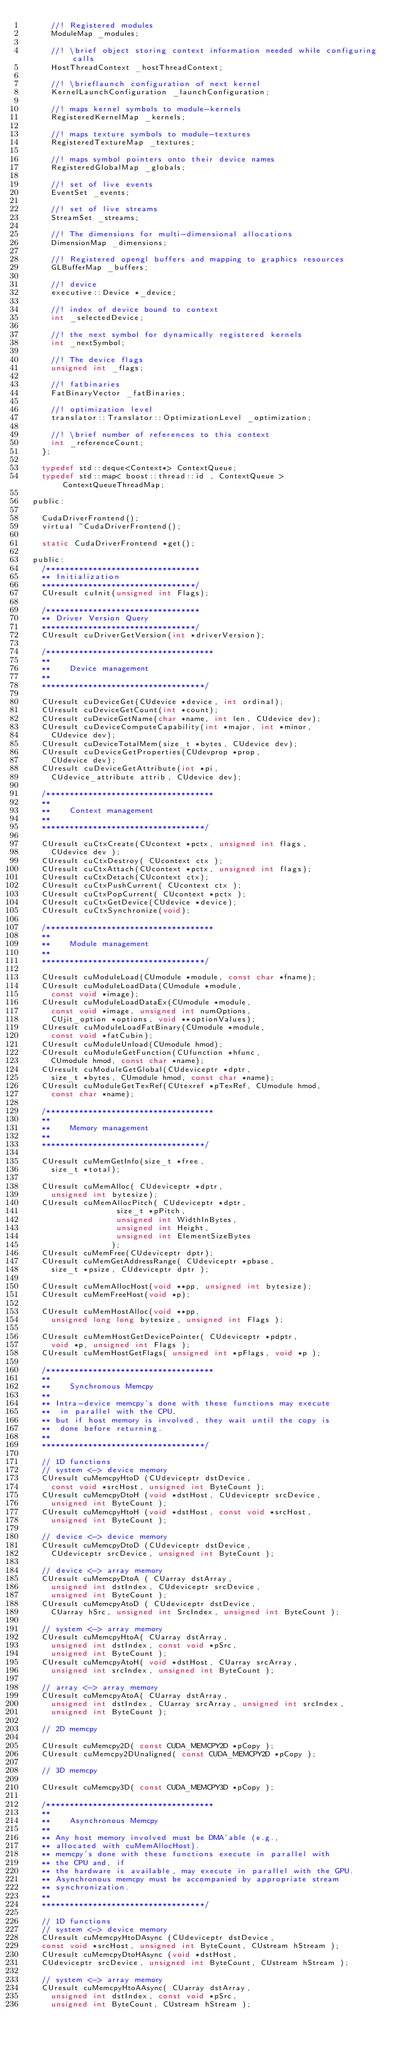<code> <loc_0><loc_0><loc_500><loc_500><_C_>			//! Registered modules
			ModuleMap _modules;
		
			//! \brief object storing context information needed while configuring calls
			HostThreadContext _hostThreadContext;
			
			//! \brieflaunch configuration of next kernel
			KernelLaunchConfiguration _launchConfiguration;
		
			//! maps kernel symbols to module-kernels
			RegisteredKernelMap _kernels;
		
			//! maps texture symbols to module-textures
			RegisteredTextureMap _textures;

			//! maps symbol pointers onto their device names
			RegisteredGlobalMap _globals;
			
			//! set of live events
			EventSet _events;
			
			//! set of live streams
			StreamSet _streams;
		
			//! The dimensions for multi-dimensional allocations
			DimensionMap _dimensions;
		
			//! Registered opengl buffers and mapping to graphics resources
			GLBufferMap _buffers;
		
			//! device
			executive::Device *_device;
			
			//! index of device bound to context
			int _selectedDevice;
		
			//! the next symbol for dynamically registered kernels
			int _nextSymbol;
		
			//! The device flags
			unsigned int _flags;
		
			//! fatbinaries
			FatBinaryVector _fatBinaries;

			//! optimization level
			translator::Translator::OptimizationLevel _optimization;

			//! \brief number of references to this context
			int _referenceCount;
		};

		typedef std::deque<Context*> ContextQueue;
		typedef std::map< boost::thread::id , ContextQueue > ContextQueueThreadMap;

	public:

		CudaDriverFrontend();
		virtual ~CudaDriverFrontend();

		static CudaDriverFrontend *get();

	public:
		/*********************************
		** Initialization
		*********************************/
		CUresult cuInit(unsigned int Flags);

		/*********************************
		** Driver Version Query
		*********************************/
		CUresult cuDriverGetVersion(int *driverVersion);

		/************************************
		**
		**    Device management
		**
		***********************************/

		CUresult cuDeviceGet(CUdevice *device, int ordinal);
		CUresult cuDeviceGetCount(int *count);
		CUresult cuDeviceGetName(char *name, int len, CUdevice dev);
		CUresult cuDeviceComputeCapability(int *major, int *minor, 
			CUdevice dev);
		CUresult cuDeviceTotalMem(size_t *bytes, CUdevice dev);
		CUresult cuDeviceGetProperties(CUdevprop *prop, 
			CUdevice dev);
		CUresult cuDeviceGetAttribute(int *pi, 
			CUdevice_attribute attrib, CUdevice dev);

		/************************************
		**
		**    Context management
		**
		***********************************/

		CUresult cuCtxCreate(CUcontext *pctx, unsigned int flags, 
			CUdevice dev );
		CUresult cuCtxDestroy( CUcontext ctx );
		CUresult cuCtxAttach(CUcontext *pctx, unsigned int flags);
		CUresult cuCtxDetach(CUcontext ctx);
		CUresult cuCtxPushCurrent( CUcontext ctx );
		CUresult cuCtxPopCurrent( CUcontext *pctx );
		CUresult cuCtxGetDevice(CUdevice *device);
		CUresult cuCtxSynchronize(void);

		/************************************
		**
		**    Module management
		**
		***********************************/

		CUresult cuModuleLoad(CUmodule *module, const char *fname);
		CUresult cuModuleLoadData(CUmodule *module, 
			const void *image);
		CUresult cuModuleLoadDataEx(CUmodule *module, 
			const void *image, unsigned int numOptions, 
			CUjit_option *options, void **optionValues);
		CUresult cuModuleLoadFatBinary(CUmodule *module, 
			const void *fatCubin);
		CUresult cuModuleUnload(CUmodule hmod);
		CUresult cuModuleGetFunction(CUfunction *hfunc, 
			CUmodule hmod, const char *name);
		CUresult cuModuleGetGlobal(CUdeviceptr *dptr, 
			size_t *bytes, CUmodule hmod, const char *name);
		CUresult cuModuleGetTexRef(CUtexref *pTexRef, CUmodule hmod, 
			const char *name);

		/************************************
		**
		**    Memory management
		**
		***********************************/

		CUresult cuMemGetInfo(size_t *free, 
			size_t *total);

		CUresult cuMemAlloc( CUdeviceptr *dptr, 
			unsigned int bytesize);
		CUresult cuMemAllocPitch( CUdeviceptr *dptr, 
					          size_t *pPitch,
					          unsigned int WidthInBytes, 
					          unsigned int Height, 
					          unsigned int ElementSizeBytes
					         );
		CUresult cuMemFree(CUdeviceptr dptr);
		CUresult cuMemGetAddressRange( CUdeviceptr *pbase, 
			size_t *psize, CUdeviceptr dptr );

		CUresult cuMemAllocHost(void **pp, unsigned int bytesize);
		CUresult cuMemFreeHost(void *p);

		CUresult cuMemHostAlloc(void **pp, 
			unsigned long long bytesize, unsigned int Flags );

		CUresult cuMemHostGetDevicePointer( CUdeviceptr *pdptr, 
			void *p, unsigned int Flags );
		CUresult cuMemHostGetFlags( unsigned int *pFlags, void *p );

		/************************************
		**
		**    Synchronous Memcpy
		**
		** Intra-device memcpy's done with these functions may execute 
		**	in parallel with the CPU,
		** but if host memory is involved, they wait until the copy is 
		**	done before returning.
		**
		***********************************/

		// 1D functions
		// system <-> device memory
		CUresult cuMemcpyHtoD (CUdeviceptr dstDevice, 
			const void *srcHost, unsigned int ByteCount );
		CUresult cuMemcpyDtoH (void *dstHost, CUdeviceptr srcDevice, 
			unsigned int ByteCount );
		CUresult cuMemcpyHtoH (void *dstHost, const void *srcHost, 
			unsigned int ByteCount );

		// device <-> device memory
		CUresult cuMemcpyDtoD (CUdeviceptr dstDevice, 
			CUdeviceptr srcDevice, unsigned int ByteCount );

		// device <-> array memory
		CUresult cuMemcpyDtoA ( CUarray dstArray, 
			unsigned int dstIndex, CUdeviceptr srcDevice, 
			unsigned int ByteCount );
		CUresult cuMemcpyAtoD ( CUdeviceptr dstDevice, 
			CUarray hSrc, unsigned int SrcIndex, unsigned int ByteCount );

		// system <-> array memory
		CUresult cuMemcpyHtoA( CUarray dstArray, 
			unsigned int dstIndex, const void *pSrc, 
			unsigned int ByteCount );
		CUresult cuMemcpyAtoH( void *dstHost, CUarray srcArray, 
			unsigned int srcIndex, unsigned int ByteCount );

		// array <-> array memory
		CUresult cuMemcpyAtoA( CUarray dstArray, 
			unsigned int dstIndex, CUarray srcArray, unsigned int srcIndex, 
			unsigned int ByteCount );

		// 2D memcpy

		CUresult cuMemcpy2D( const CUDA_MEMCPY2D *pCopy );
		CUresult cuMemcpy2DUnaligned( const CUDA_MEMCPY2D *pCopy );

		// 3D memcpy

		CUresult cuMemcpy3D( const CUDA_MEMCPY3D *pCopy );

		/************************************
		**
		**    Asynchronous Memcpy
		**
		** Any host memory involved must be DMA'able (e.g., 
		** allocated with cuMemAllocHost).
		** memcpy's done with these functions execute in parallel with 
		** the CPU and, if
		** the hardware is available, may execute in parallel with the GPU.
		** Asynchronous memcpy must be accompanied by appropriate stream 
		** synchronization.
		**
		***********************************/

		// 1D functions
		// system <-> device memory
		CUresult cuMemcpyHtoDAsync (CUdeviceptr dstDevice, 
		const void *srcHost, unsigned int ByteCount, CUstream hStream );
		CUresult cuMemcpyDtoHAsync (void *dstHost, 
		CUdeviceptr srcDevice, unsigned int ByteCount, CUstream hStream );

		// system <-> array memory
		CUresult cuMemcpyHtoAAsync( CUarray dstArray, 
			unsigned int dstIndex, const void *pSrc, 
			unsigned int ByteCount, CUstream hStream );</code> 